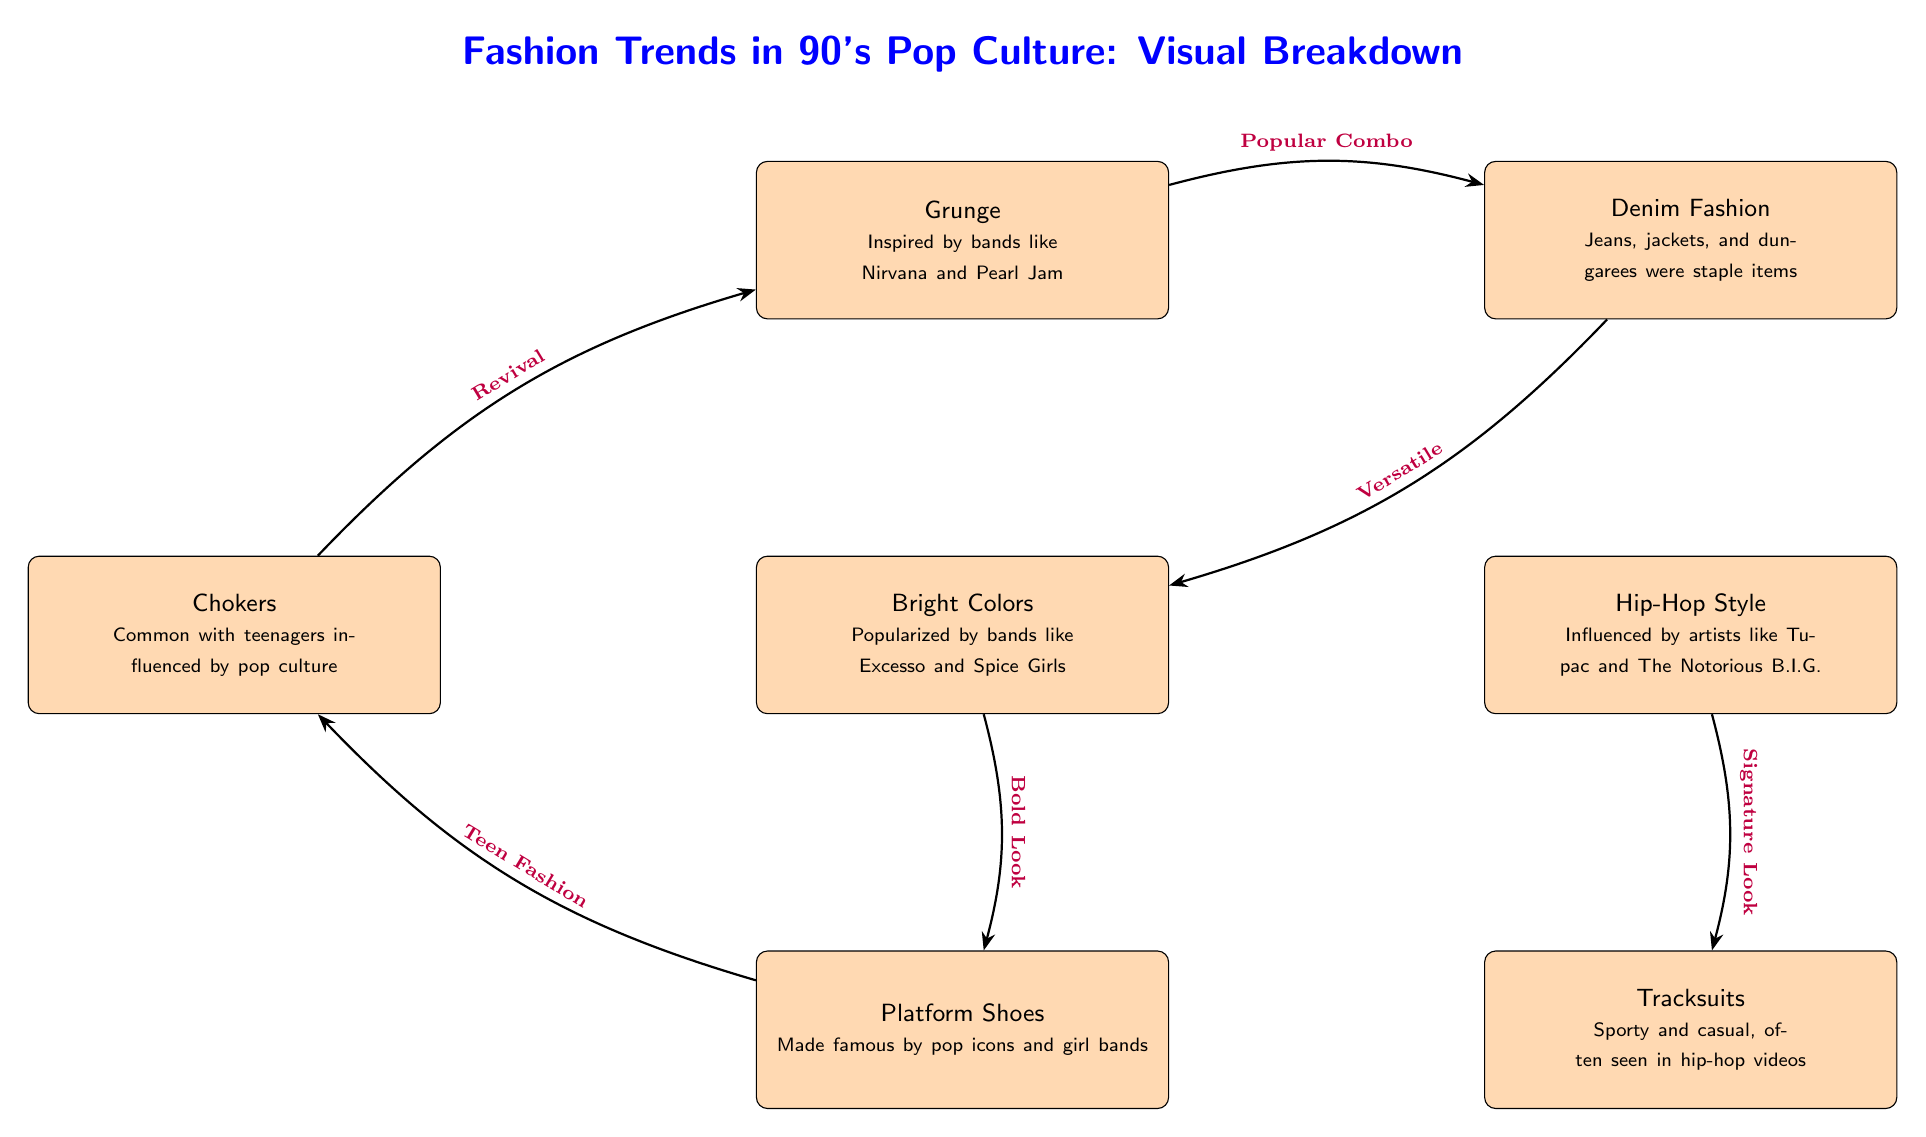What are the staple items in Denim Fashion? The node labeled "Denim Fashion" lists "Jeans, jackets, and dungarees were staple items" as its description.
Answer: Jeans, jackets, and dungarees What style is influenced by Tupac and The Notorious B.I.G.? The node labeled "Hip-Hop Style" mentions influences from artists like Tupac and The Notorious B.I.G.
Answer: Hip-Hop Style Which fashion trend is marked as a "Bold Look"? The connection between "Bright Colors" and "Platform Shoes" identifies the "Bold Look" associated with "Bright Colors".
Answer: Bright Colors How many fashion trends are mentioned in the diagram? Upon counting the nodes, there are a total of six distinct fashion trends represented in the diagram.
Answer: Six What is a common accessory seen in 90's fashion as per the diagram? The node for "Chokers" highlights them as common with teenagers influenced by pop culture.
Answer: Chokers Which two trends are directly connected through the label "Revival"? The connection labeled "Revival" links "Chokers" to "Grunge", indicating a relationship in terms of trends.
Answer: Chokers and Grunge What type of look is associated with Tracksuits? The description in the "Tracksuits" node states they are "Sporty and casual," pointing to their overall style.
Answer: Sporty and casual Which fashion trend is described as a "Signature Look"? The connection labeled "Signature Look" relates the "Hip-Hop Style" to "Tracksuits".
Answer: Hip-Hop Style What color style was popularized by bands like Excesso? The "Bright Colors" node specifically states it was popularized by bands like Excesso and Spice Girls.
Answer: Bright Colors 